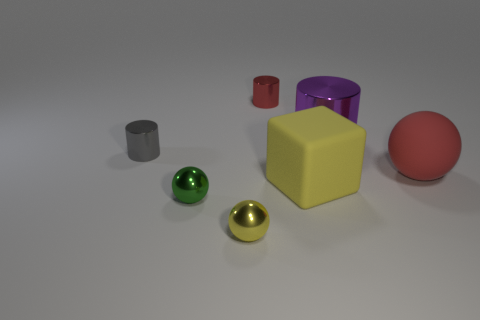Subtract all red cylinders. How many cylinders are left? 2 Add 2 small yellow spheres. How many objects exist? 9 Subtract 2 cylinders. How many cylinders are left? 1 Subtract all cubes. How many objects are left? 6 Subtract all green cylinders. How many green balls are left? 1 Subtract all green spheres. How many spheres are left? 2 Subtract all brown cubes. Subtract all red cylinders. How many cubes are left? 1 Add 2 large objects. How many large objects exist? 5 Subtract 1 purple cylinders. How many objects are left? 6 Subtract all yellow metallic things. Subtract all big red matte things. How many objects are left? 5 